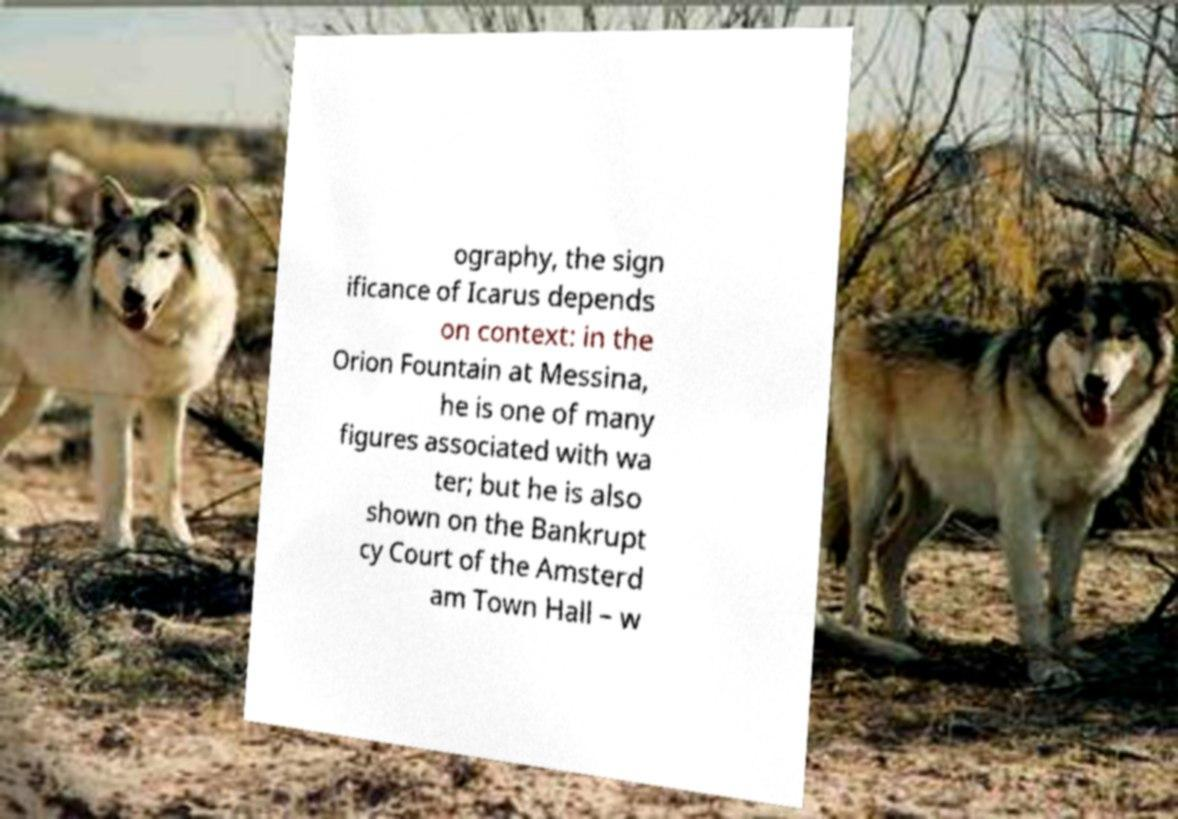There's text embedded in this image that I need extracted. Can you transcribe it verbatim? ography, the sign ificance of Icarus depends on context: in the Orion Fountain at Messina, he is one of many figures associated with wa ter; but he is also shown on the Bankrupt cy Court of the Amsterd am Town Hall – w 